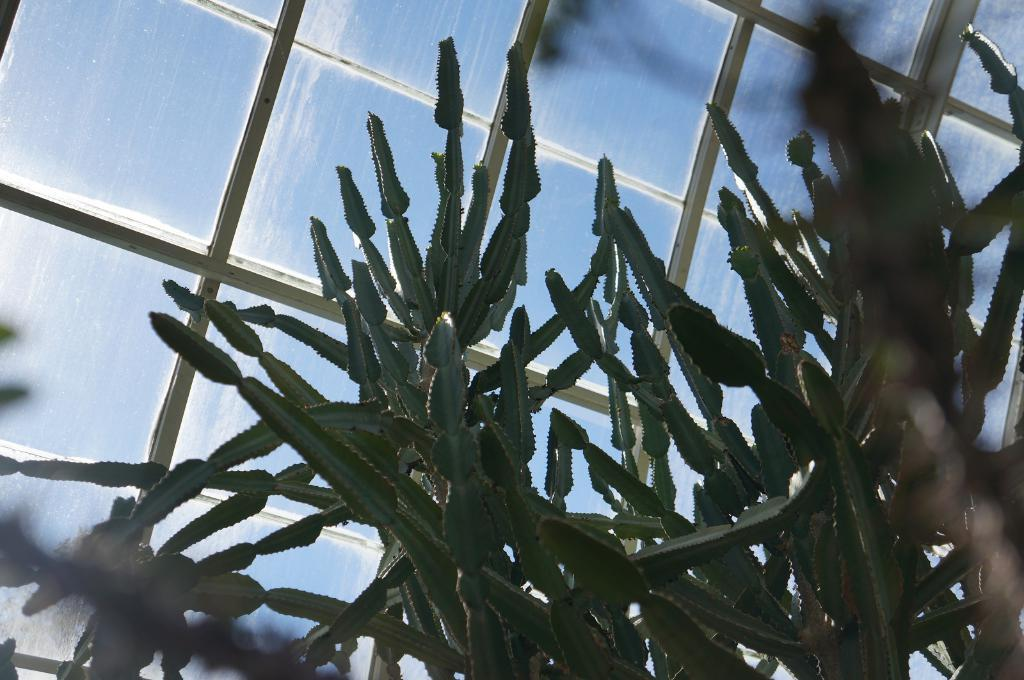What type of plant is present in the image? There is a cactus in the image. What can be seen in the background of the image? There is a window in the background of the image. What type of string is being used to decorate the trees in the scene? There are no trees or string present in the image; it only features a cactus and a window in the background. 